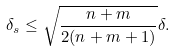<formula> <loc_0><loc_0><loc_500><loc_500>\delta _ { s } \leq \sqrt { \frac { n + m } { 2 ( n + m + 1 ) } } \delta .</formula> 